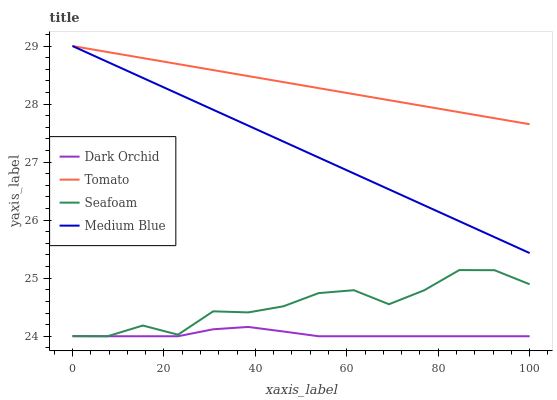Does Dark Orchid have the minimum area under the curve?
Answer yes or no. Yes. Does Tomato have the maximum area under the curve?
Answer yes or no. Yes. Does Medium Blue have the minimum area under the curve?
Answer yes or no. No. Does Medium Blue have the maximum area under the curve?
Answer yes or no. No. Is Tomato the smoothest?
Answer yes or no. Yes. Is Seafoam the roughest?
Answer yes or no. Yes. Is Medium Blue the smoothest?
Answer yes or no. No. Is Medium Blue the roughest?
Answer yes or no. No. Does Seafoam have the lowest value?
Answer yes or no. Yes. Does Medium Blue have the lowest value?
Answer yes or no. No. Does Medium Blue have the highest value?
Answer yes or no. Yes. Does Seafoam have the highest value?
Answer yes or no. No. Is Seafoam less than Medium Blue?
Answer yes or no. Yes. Is Tomato greater than Dark Orchid?
Answer yes or no. Yes. Does Dark Orchid intersect Seafoam?
Answer yes or no. Yes. Is Dark Orchid less than Seafoam?
Answer yes or no. No. Is Dark Orchid greater than Seafoam?
Answer yes or no. No. Does Seafoam intersect Medium Blue?
Answer yes or no. No. 